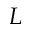Convert formula to latex. <formula><loc_0><loc_0><loc_500><loc_500>L</formula> 